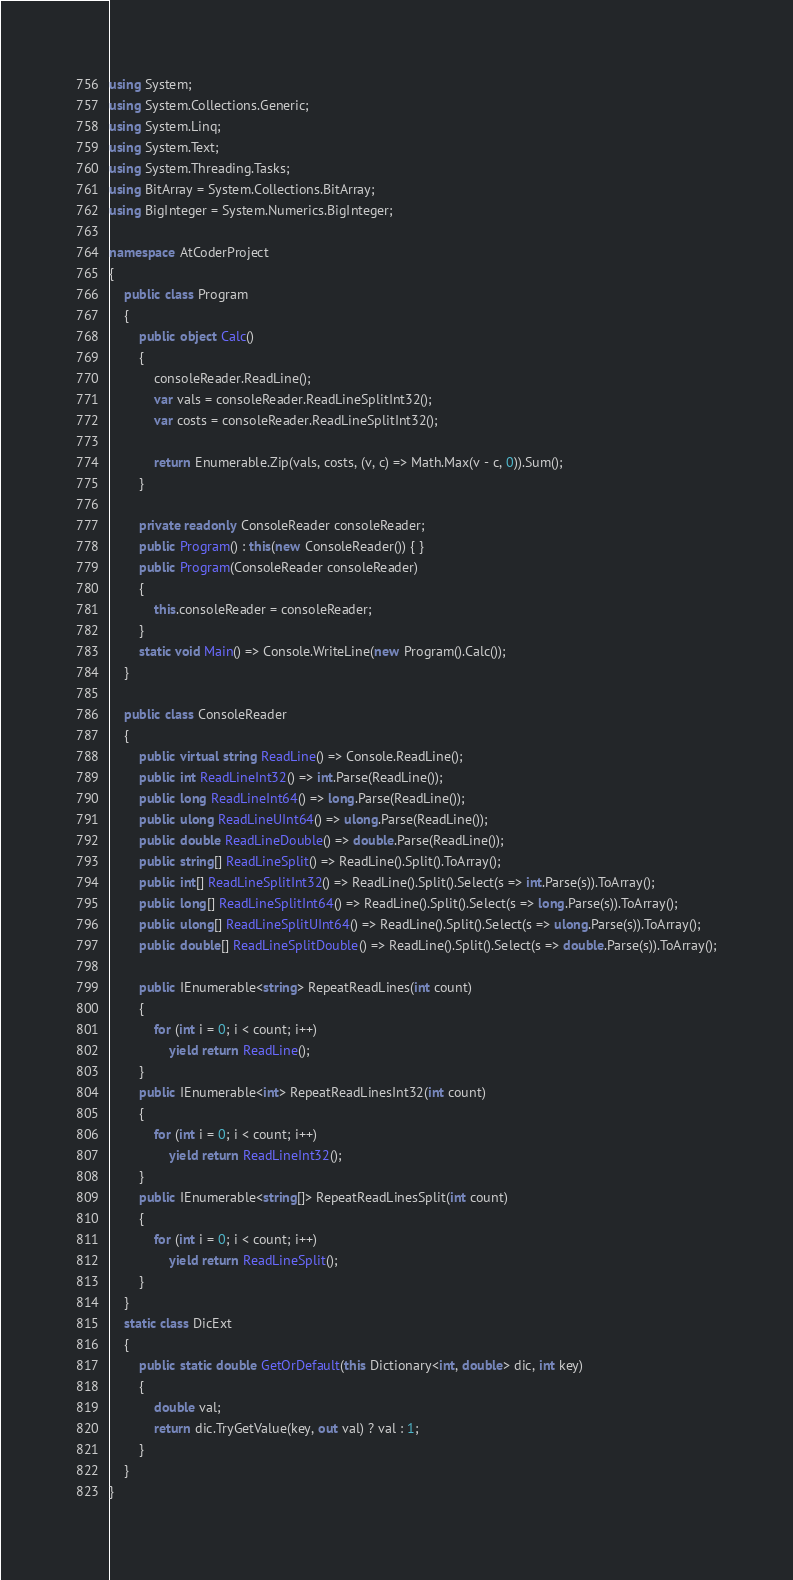Convert code to text. <code><loc_0><loc_0><loc_500><loc_500><_C#_>using System;
using System.Collections.Generic;
using System.Linq;
using System.Text;
using System.Threading.Tasks;
using BitArray = System.Collections.BitArray;
using BigInteger = System.Numerics.BigInteger;

namespace AtCoderProject
{
    public class Program
    {
        public object Calc()
        {
            consoleReader.ReadLine();
            var vals = consoleReader.ReadLineSplitInt32();
            var costs = consoleReader.ReadLineSplitInt32();

            return Enumerable.Zip(vals, costs, (v, c) => Math.Max(v - c, 0)).Sum();
        }

        private readonly ConsoleReader consoleReader;
        public Program() : this(new ConsoleReader()) { }
        public Program(ConsoleReader consoleReader)
        {
            this.consoleReader = consoleReader;
        }
        static void Main() => Console.WriteLine(new Program().Calc());
    }

    public class ConsoleReader
    {
        public virtual string ReadLine() => Console.ReadLine();
        public int ReadLineInt32() => int.Parse(ReadLine());
        public long ReadLineInt64() => long.Parse(ReadLine());
        public ulong ReadLineUInt64() => ulong.Parse(ReadLine());
        public double ReadLineDouble() => double.Parse(ReadLine());
        public string[] ReadLineSplit() => ReadLine().Split().ToArray();
        public int[] ReadLineSplitInt32() => ReadLine().Split().Select(s => int.Parse(s)).ToArray();
        public long[] ReadLineSplitInt64() => ReadLine().Split().Select(s => long.Parse(s)).ToArray();
        public ulong[] ReadLineSplitUInt64() => ReadLine().Split().Select(s => ulong.Parse(s)).ToArray();
        public double[] ReadLineSplitDouble() => ReadLine().Split().Select(s => double.Parse(s)).ToArray();

        public IEnumerable<string> RepeatReadLines(int count)
        {
            for (int i = 0; i < count; i++)
                yield return ReadLine();
        }
        public IEnumerable<int> RepeatReadLinesInt32(int count)
        {
            for (int i = 0; i < count; i++)
                yield return ReadLineInt32();
        }
        public IEnumerable<string[]> RepeatReadLinesSplit(int count)
        {
            for (int i = 0; i < count; i++)
                yield return ReadLineSplit();
        }
    }
    static class DicExt
    {
        public static double GetOrDefault(this Dictionary<int, double> dic, int key)
        {
            double val;
            return dic.TryGetValue(key, out val) ? val : 1;
        }
    }
}
</code> 